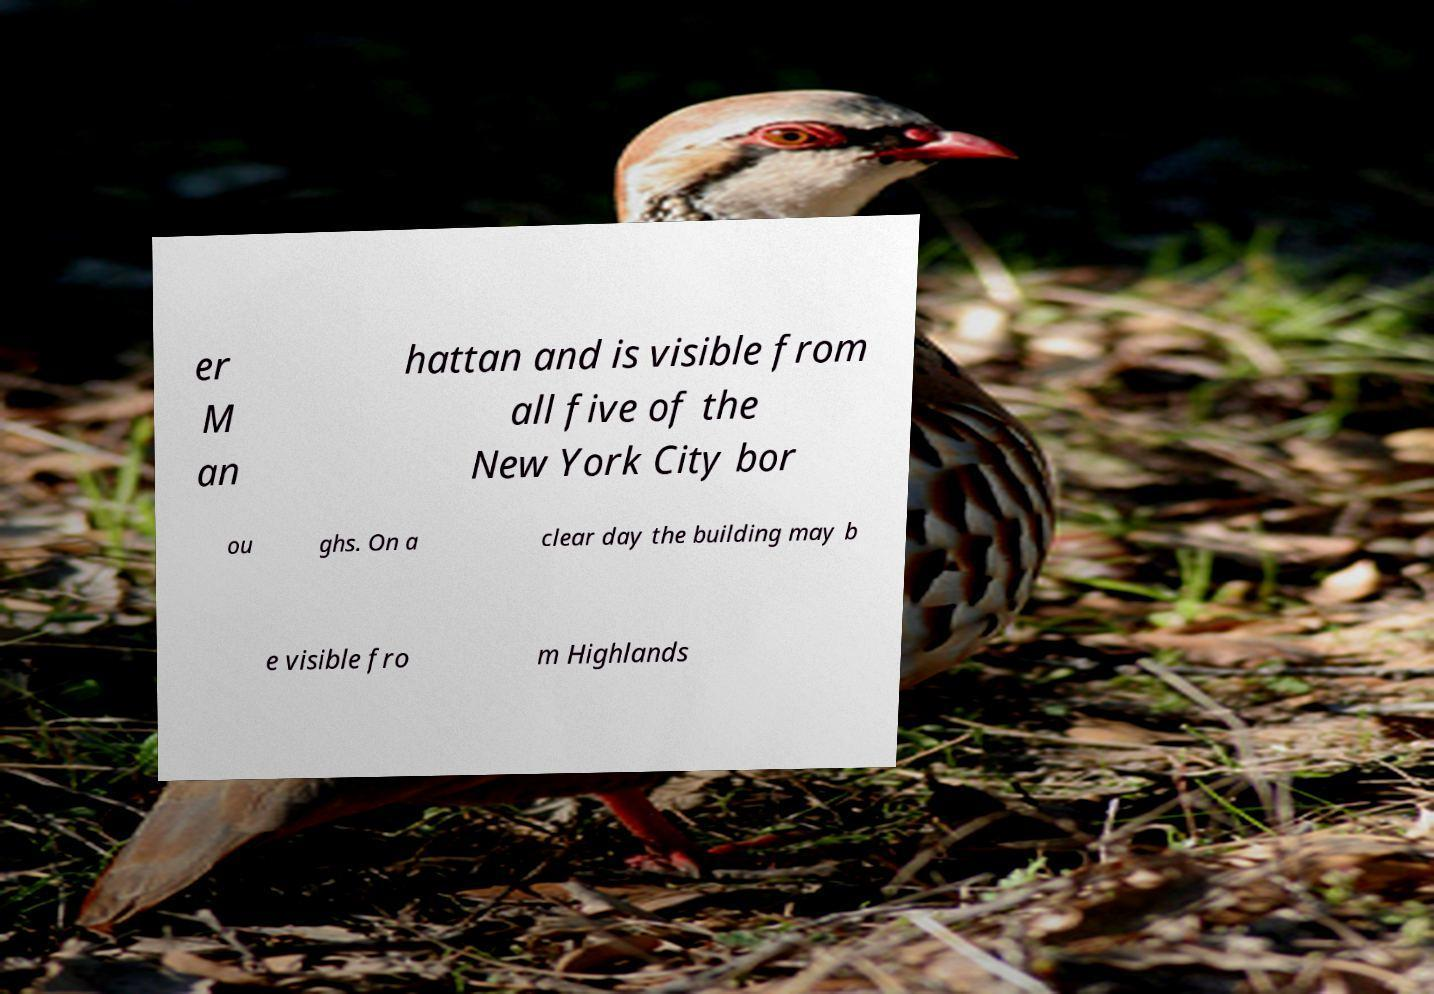For documentation purposes, I need the text within this image transcribed. Could you provide that? er M an hattan and is visible from all five of the New York City bor ou ghs. On a clear day the building may b e visible fro m Highlands 